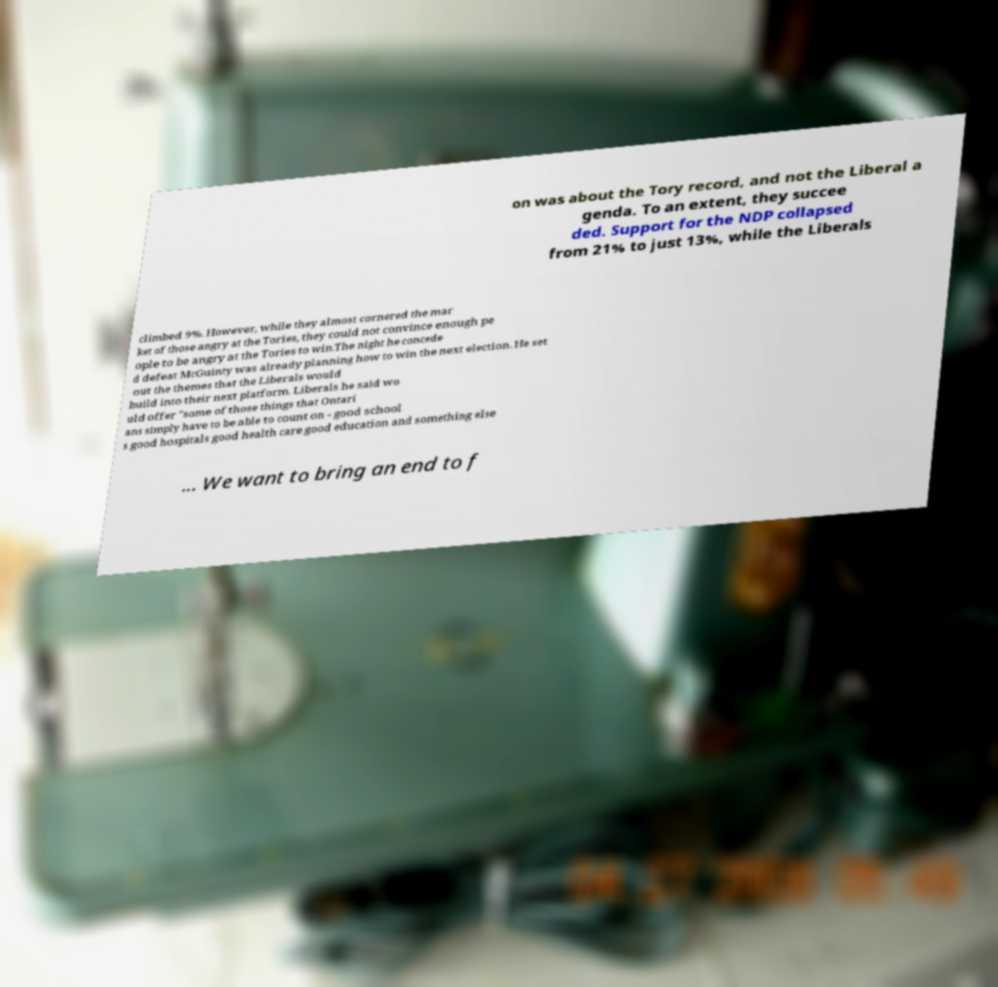Please identify and transcribe the text found in this image. on was about the Tory record, and not the Liberal a genda. To an extent, they succee ded. Support for the NDP collapsed from 21% to just 13%, while the Liberals climbed 9%. However, while they almost cornered the mar ket of those angry at the Tories, they could not convince enough pe ople to be angry at the Tories to win.The night he concede d defeat McGuinty was already planning how to win the next election. He set out the themes that the Liberals would build into their next platform. Liberals he said wo uld offer "some of those things that Ontari ans simply have to be able to count on - good school s good hospitals good health care good education and something else ... We want to bring an end to f 